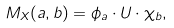Convert formula to latex. <formula><loc_0><loc_0><loc_500><loc_500>M _ { X } ( a , b ) = \phi _ { a } \cdot U \cdot \chi _ { b } ,</formula> 